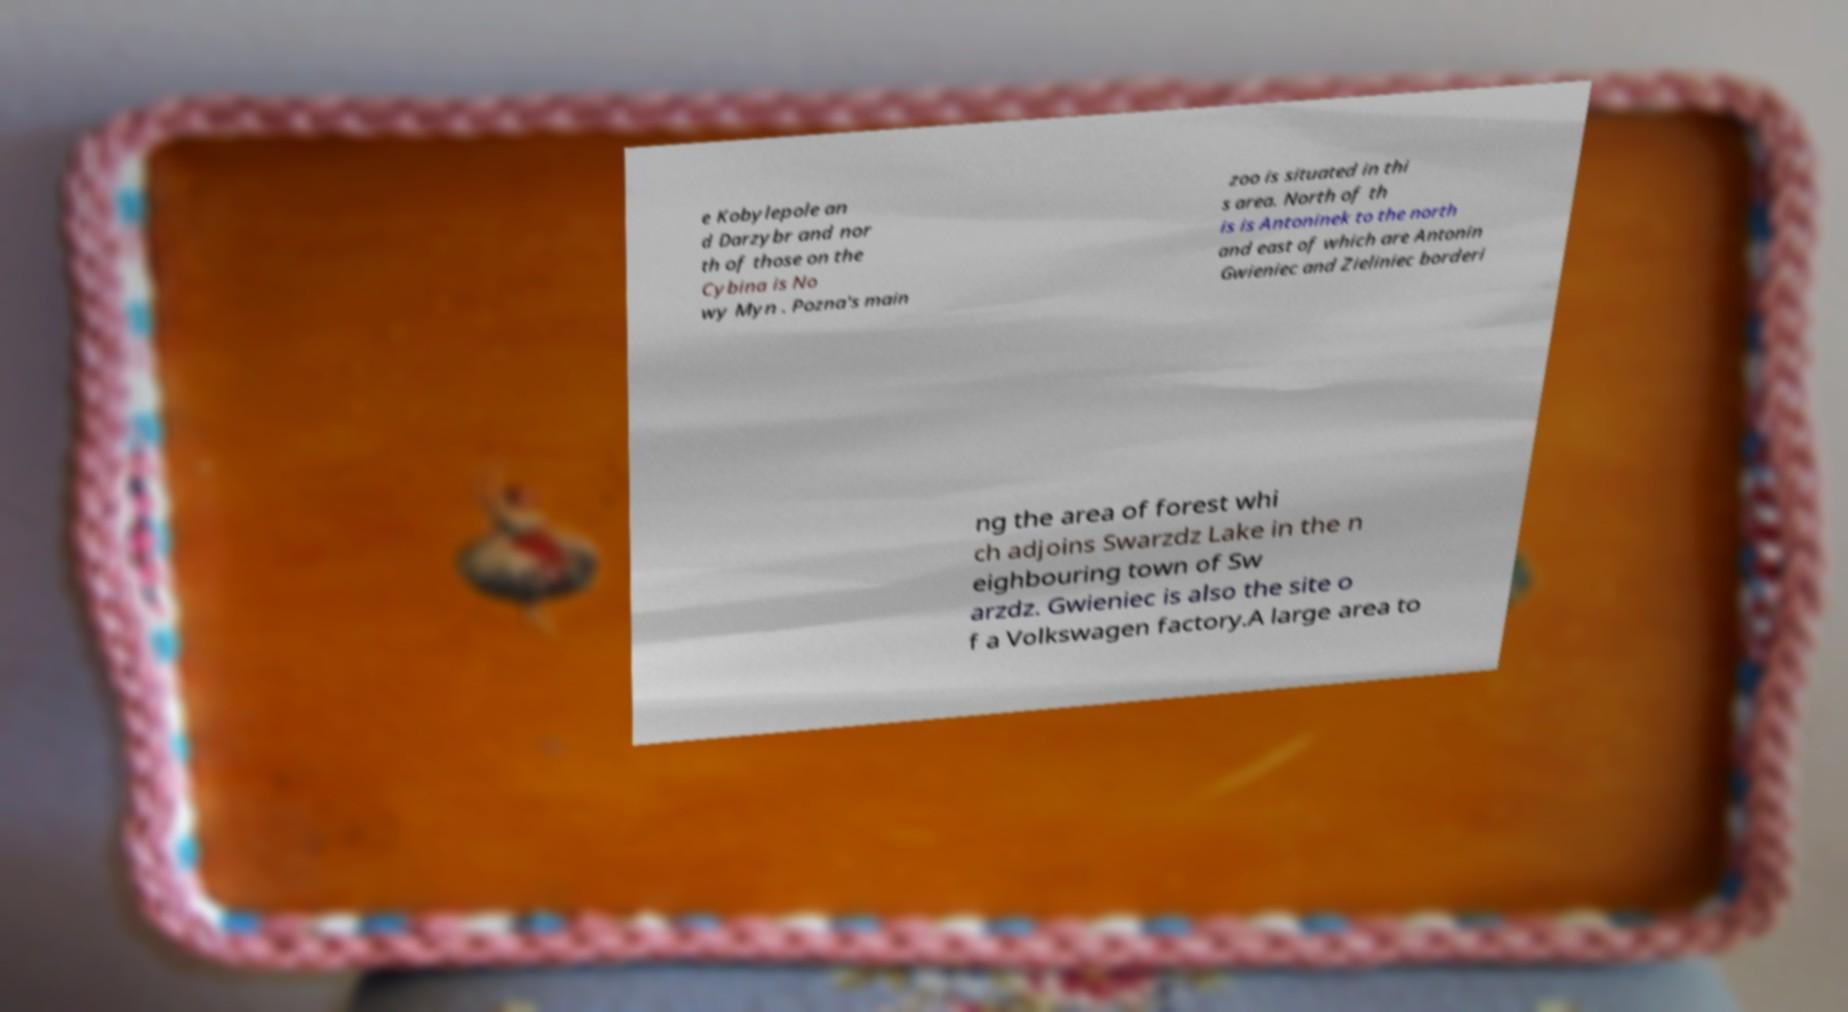There's text embedded in this image that I need extracted. Can you transcribe it verbatim? e Kobylepole an d Darzybr and nor th of those on the Cybina is No wy Myn . Pozna's main zoo is situated in thi s area. North of th is is Antoninek to the north and east of which are Antonin Gwieniec and Zieliniec borderi ng the area of forest whi ch adjoins Swarzdz Lake in the n eighbouring town of Sw arzdz. Gwieniec is also the site o f a Volkswagen factory.A large area to 